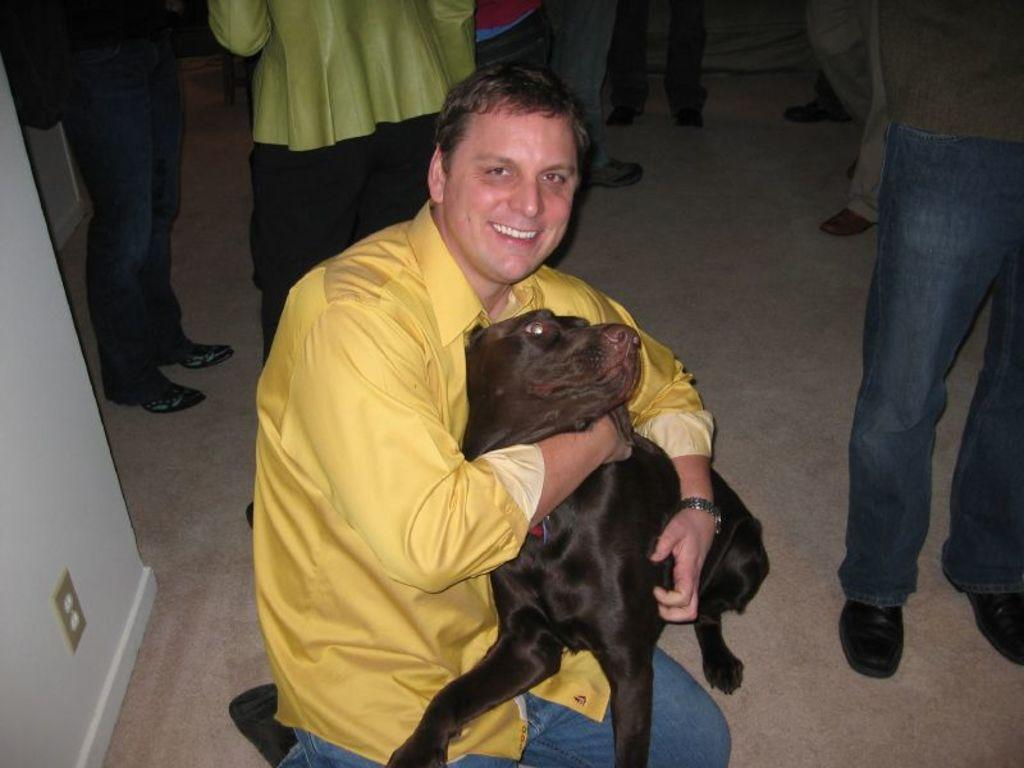What is the position of the man in the image? The man is sitting on the floor in the image. What is the man doing with his hands? The man is holding a dog in his hands. What is the man's facial expression? The man is smiling in the image. Can you describe the people behind the man? There is a group of people behind the man, and they are standing on the floor. What type of bun is the man using to hold the dog in the image? There is no bun present in the image; the man is holding the dog with his hands. 